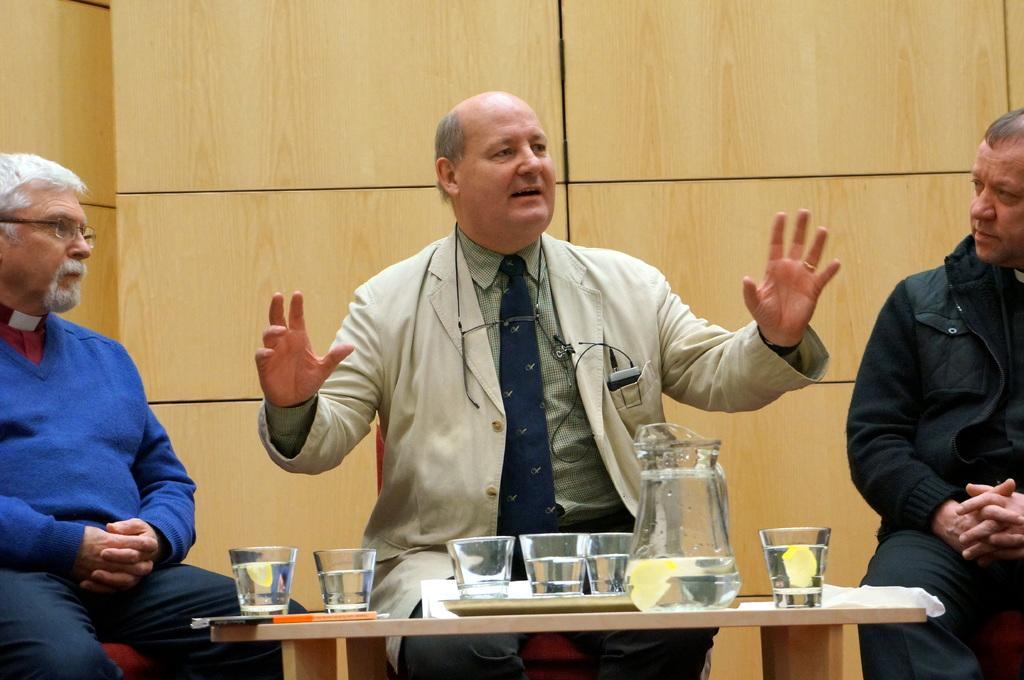How many people are in the image? There are three people in the image. Can you describe the seating arrangement of the people? One person is sitting on the left, one person is sitting on the right, and one person is sitting in the middle. What can be seen on the table in the image? There are glasses and a mug on the table. What type of cheese can be seen on the table in the image? There is no cheese present in the image. 